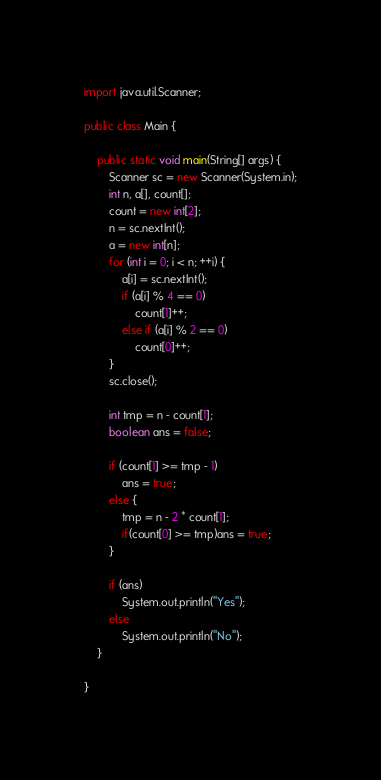Convert code to text. <code><loc_0><loc_0><loc_500><loc_500><_Java_>import java.util.Scanner;

public class Main {

	public static void main(String[] args) {
		Scanner sc = new Scanner(System.in);
		int n, a[], count[];
		count = new int[2];
		n = sc.nextInt();
		a = new int[n];
		for (int i = 0; i < n; ++i) {
			a[i] = sc.nextInt();
			if (a[i] % 4 == 0)
				count[1]++;
			else if (a[i] % 2 == 0)
				count[0]++;
		}
		sc.close();

		int tmp = n - count[1];
		boolean ans = false;

		if (count[1] >= tmp - 1)
			ans = true;
		else {
			tmp = n - 2 * count[1];
			if(count[0] >= tmp)ans = true;
		}

		if (ans)
			System.out.println("Yes");
		else
			System.out.println("No");
	}

}
</code> 